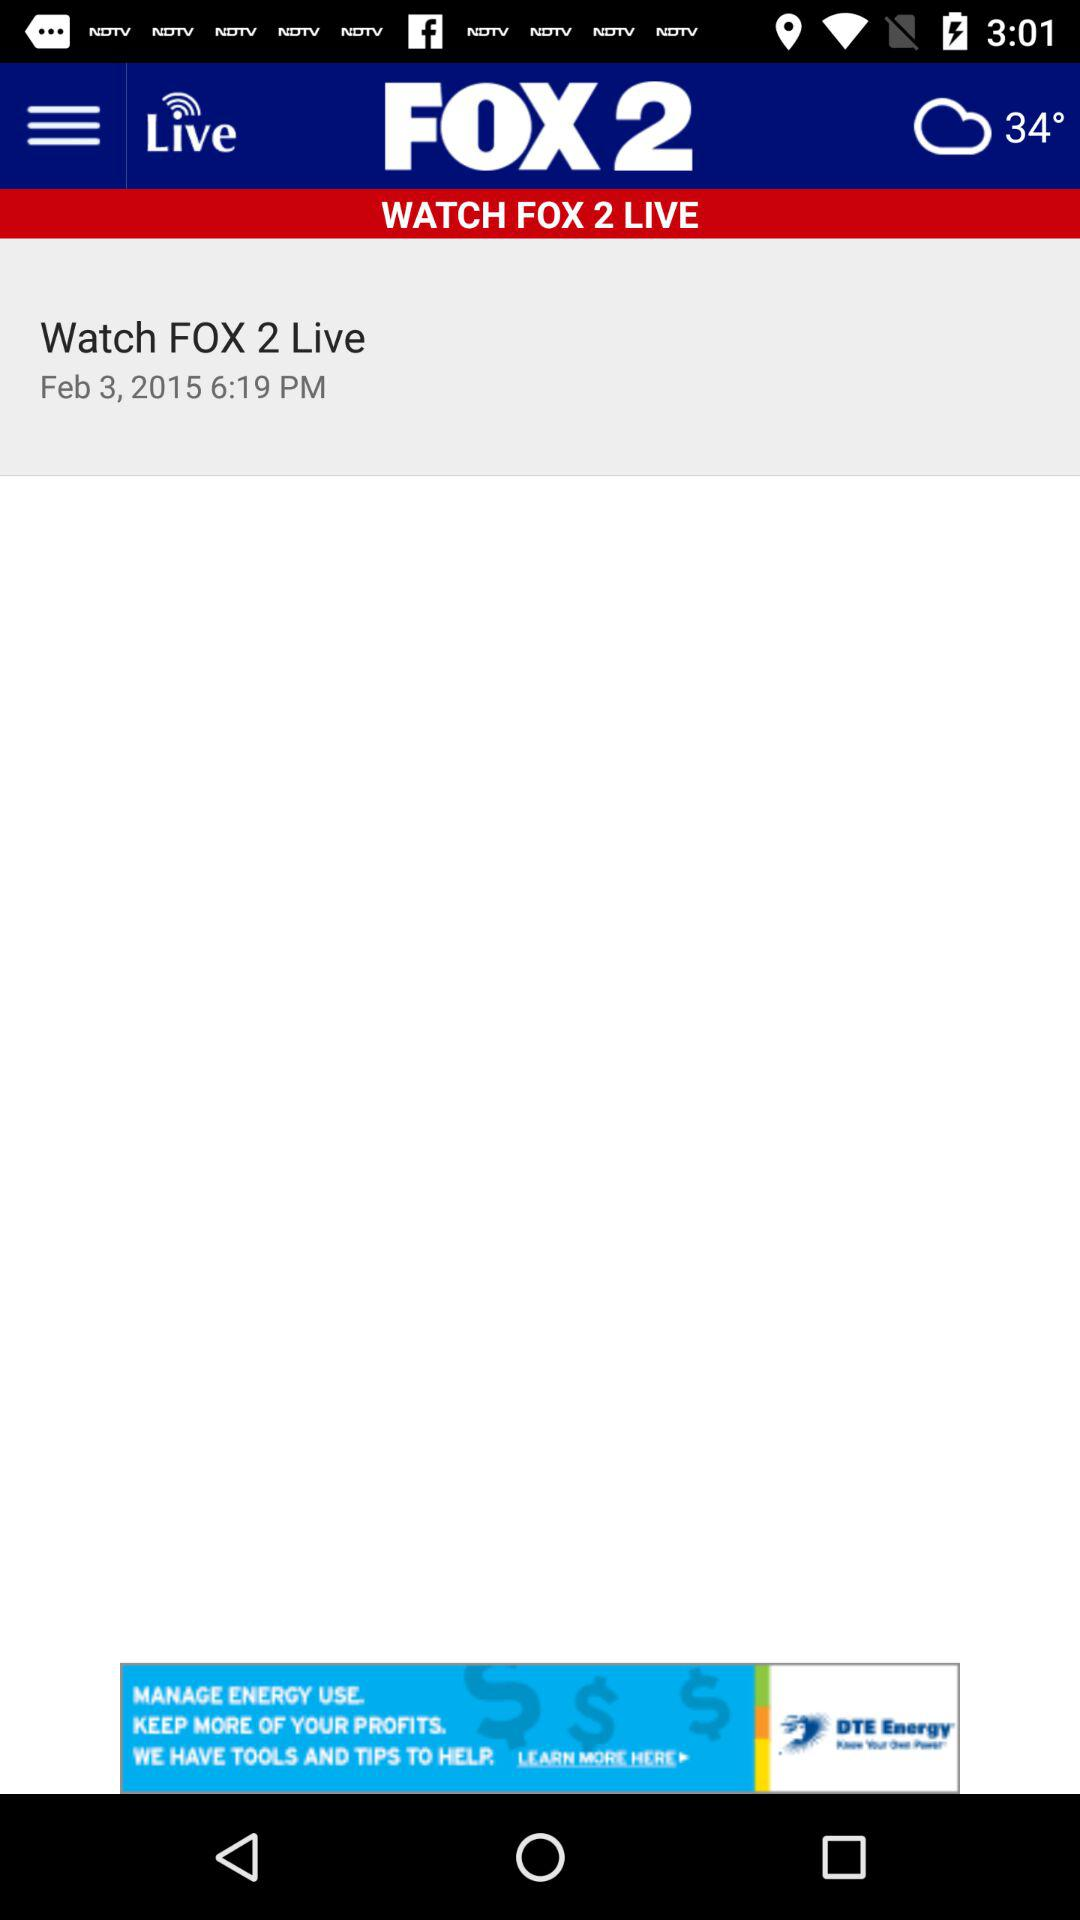What is the temperature? The temperature is 34°. 